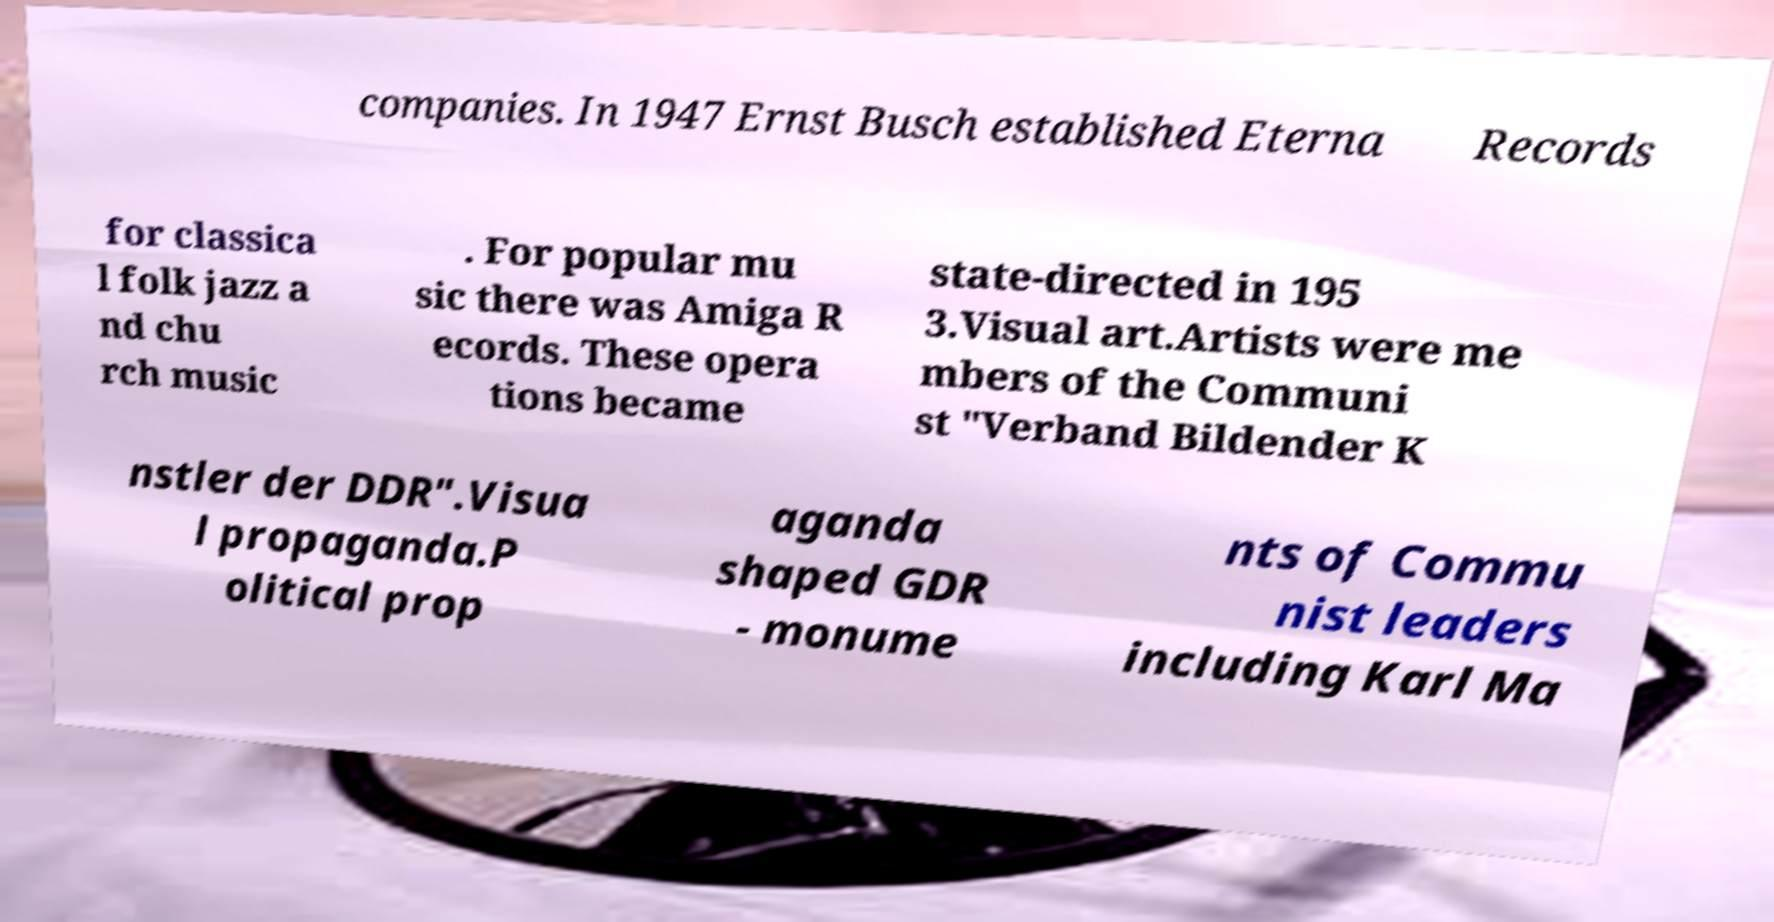Please read and relay the text visible in this image. What does it say? companies. In 1947 Ernst Busch established Eterna Records for classica l folk jazz a nd chu rch music . For popular mu sic there was Amiga R ecords. These opera tions became state-directed in 195 3.Visual art.Artists were me mbers of the Communi st "Verband Bildender K nstler der DDR".Visua l propaganda.P olitical prop aganda shaped GDR - monume nts of Commu nist leaders including Karl Ma 